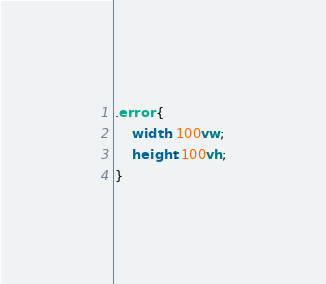Convert code to text. <code><loc_0><loc_0><loc_500><loc_500><_CSS_>.error {
    width: 100vw;
    height: 100vh;
}
</code> 